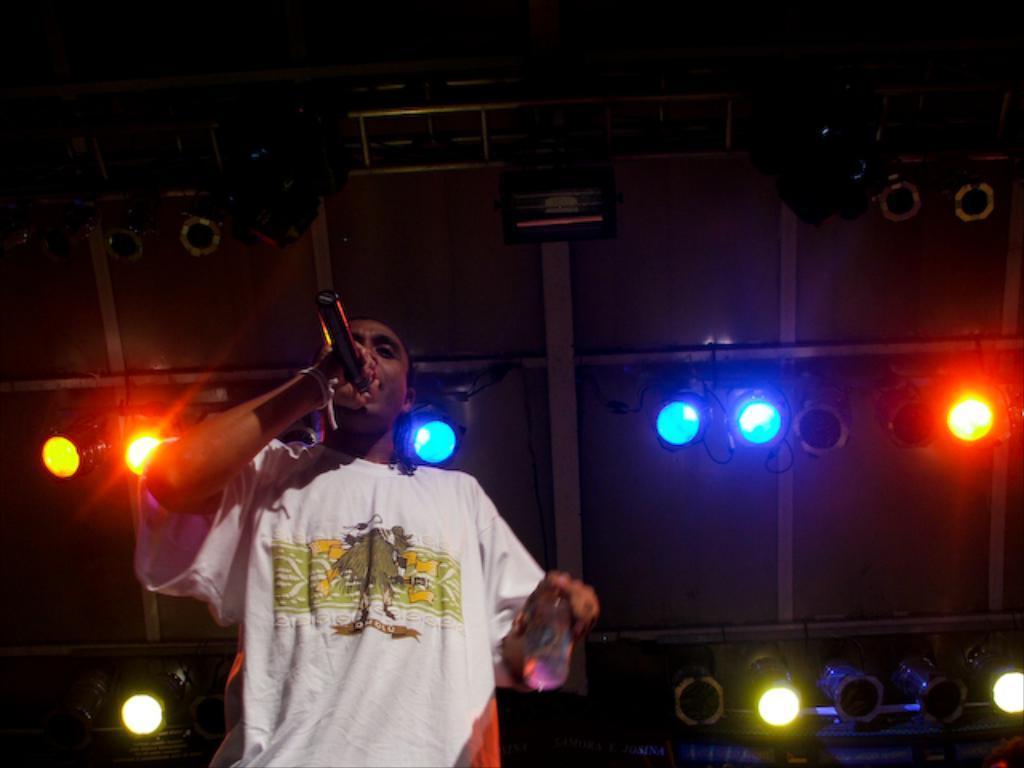How would you summarize this image in a sentence or two? In the picture we can see a person wearing white color T-shirt is holding a mic and singing. The background of the image is dark, where we can see the show lights. 